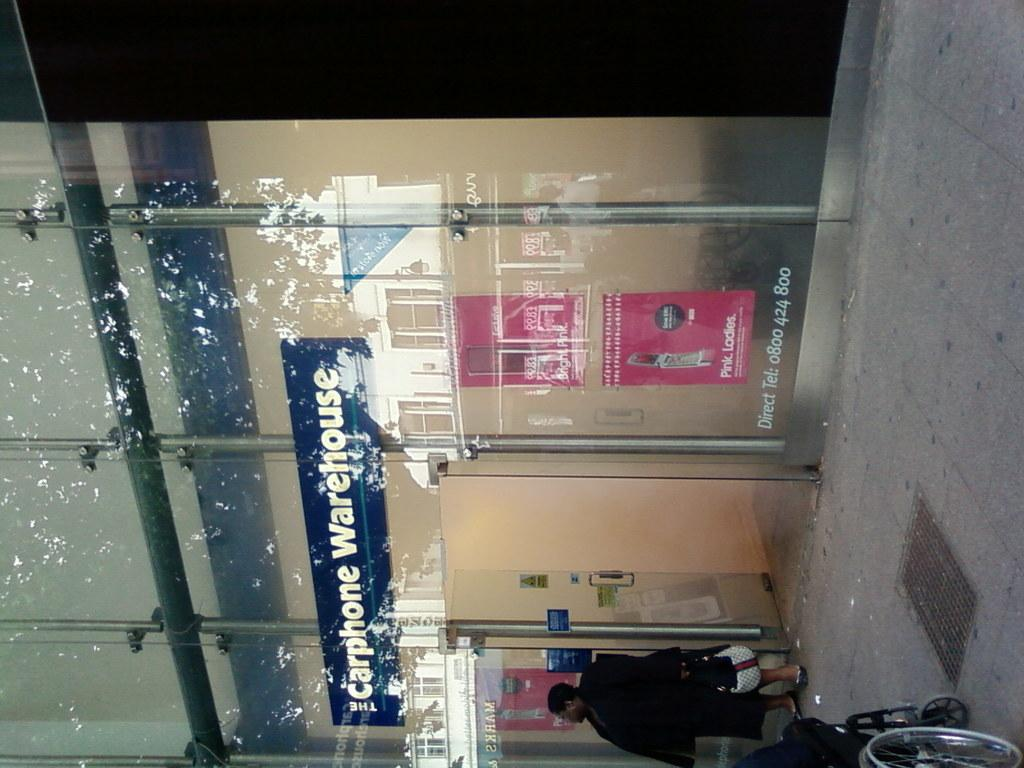What type of establishment is depicted in the image? There is a big shop in the image. What material is used for the shop's windows? The shop has glass windows. What is written on the glass of the shop? The words "Carphone Warehouse" are written on the glass. What type of fuel is being sold at the thrill shop in the image? There is no thrill shop or fuel mentioned in the image; it features a big shop with the words "Carphone Warehouse" written on the glass. 